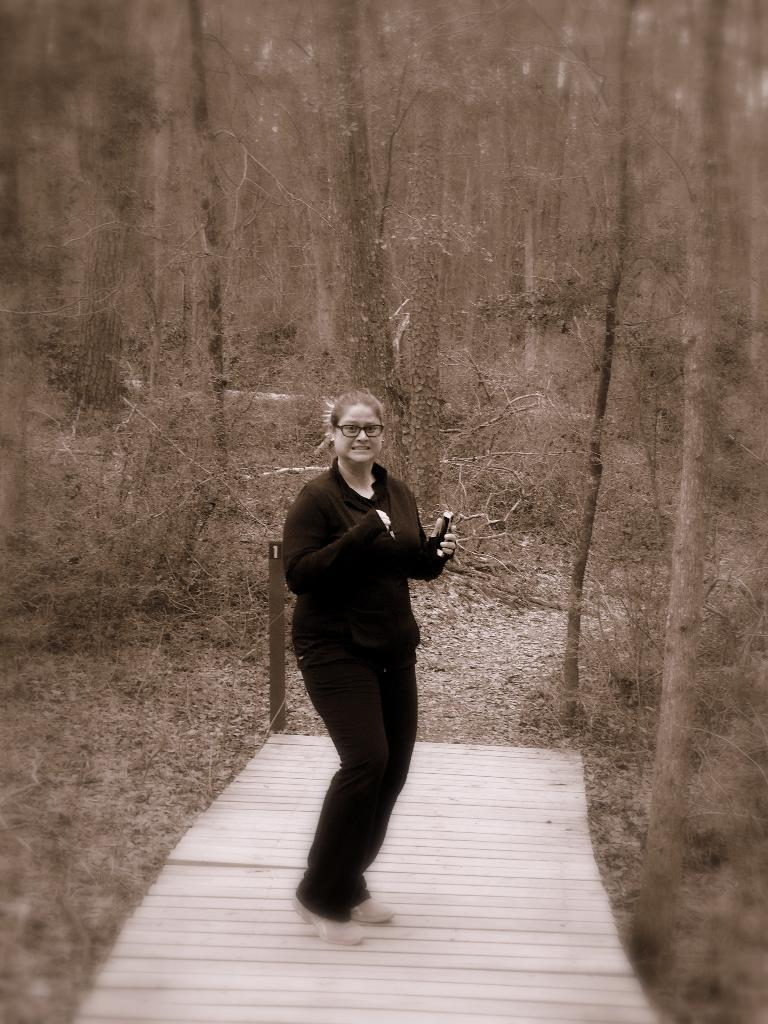What is the primary subject of the image? There is a woman standing in the image. Can you describe any accessories the woman is wearing? The woman is wearing glasses. What type of natural scenery can be seen in the background? There are trees visible behind the woman. What type of patch is the woman sewing onto her shirt in the image? There is no patch or sewing activity visible in the image. 